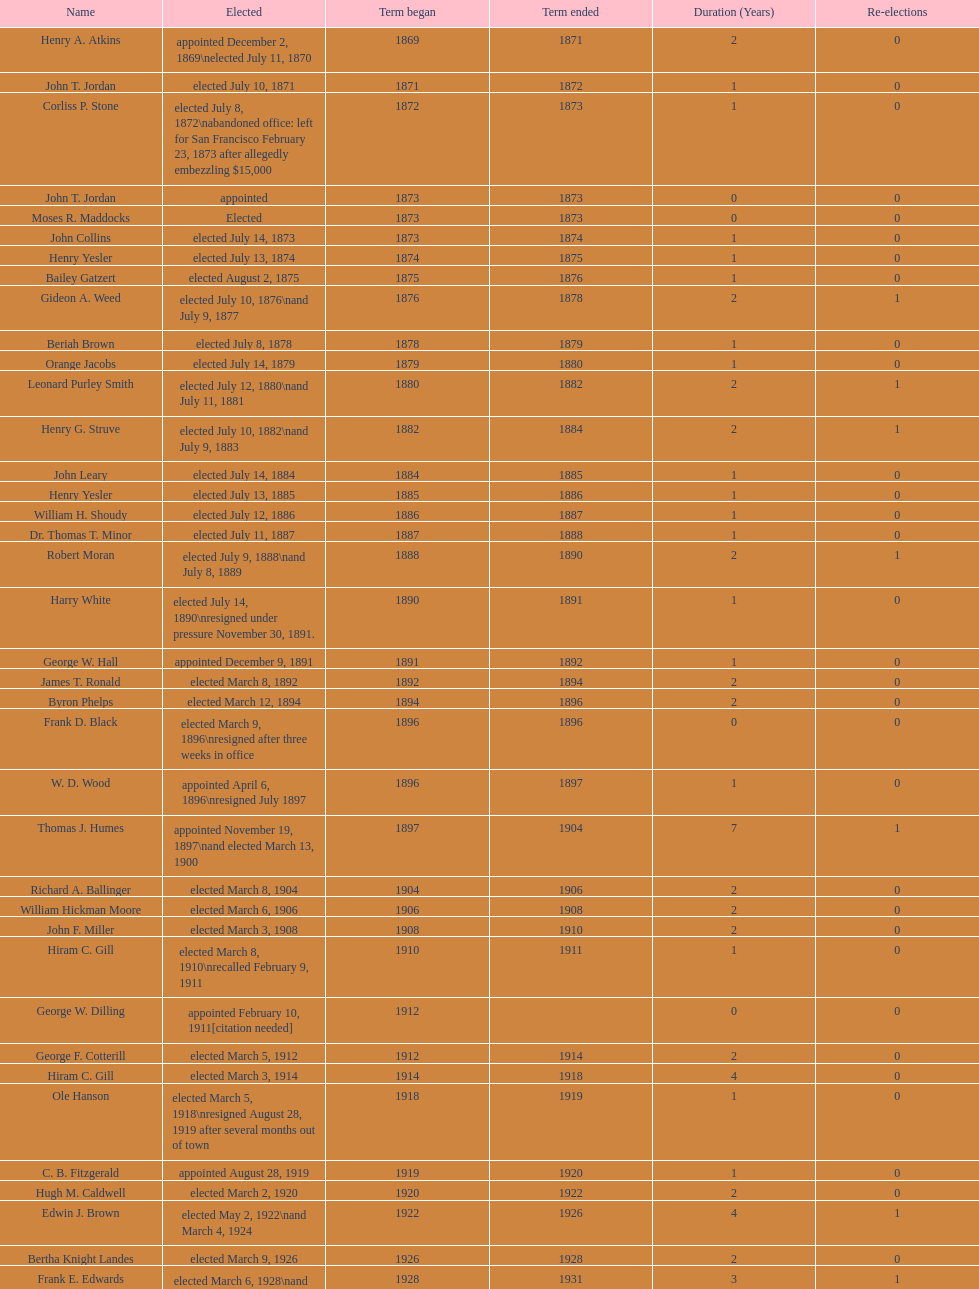Who took on the role of the first mayor in the 20th century? Richard A. Ballinger. 